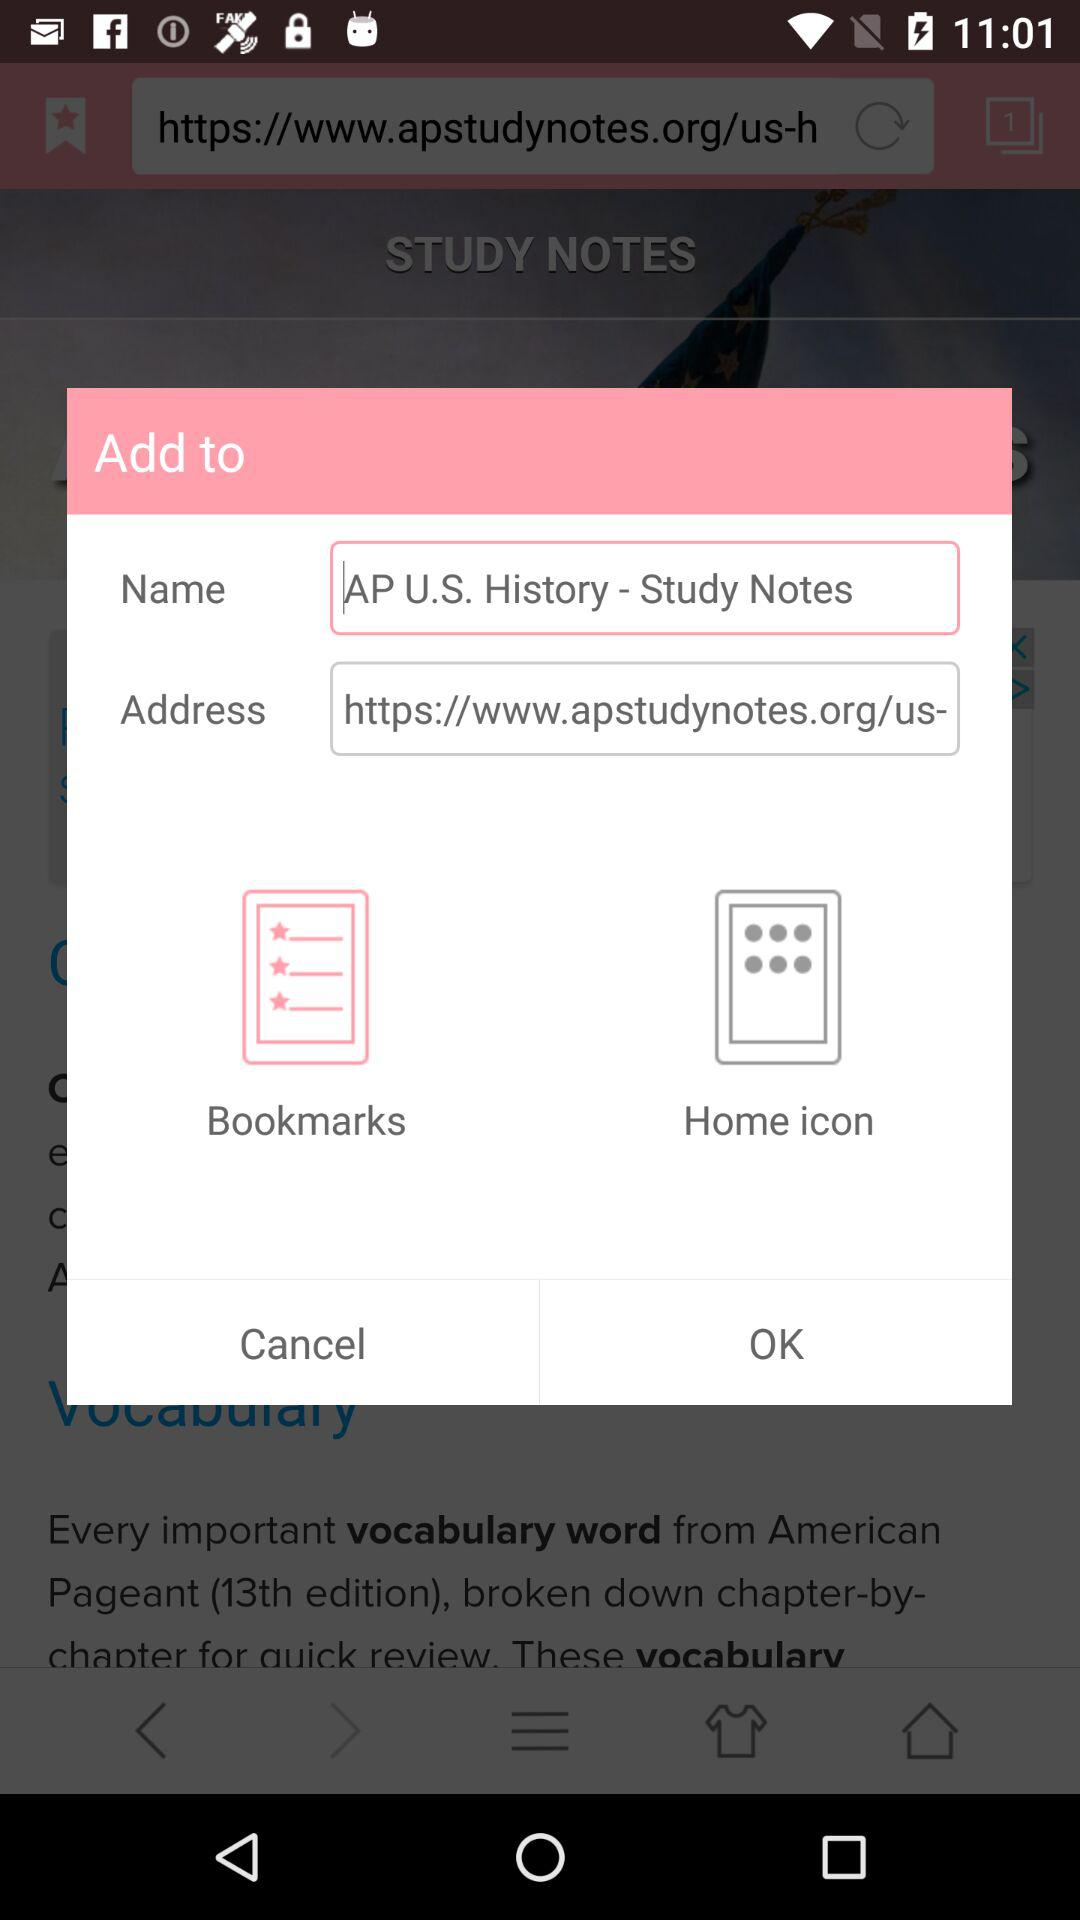How many text inputs are in the form?
Answer the question using a single word or phrase. 2 